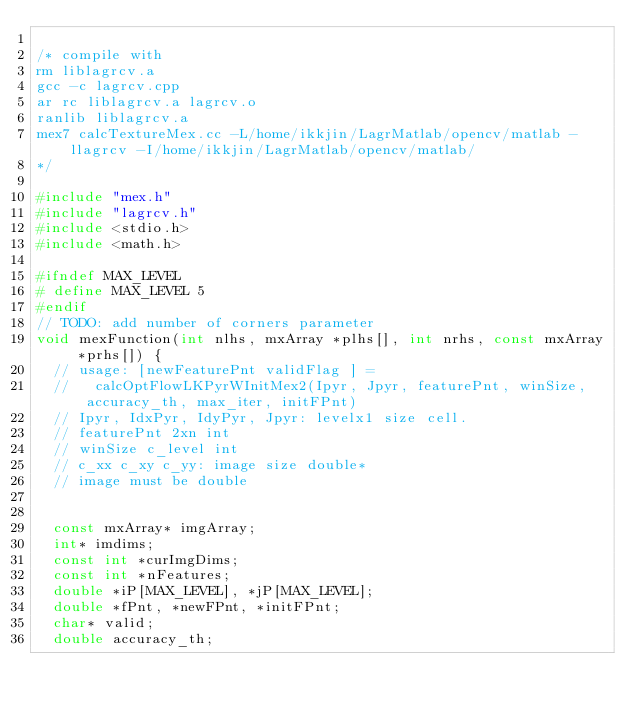<code> <loc_0><loc_0><loc_500><loc_500><_C++_>
/* compile with 
rm liblagrcv.a
gcc -c lagrcv.cpp
ar rc liblagrcv.a lagrcv.o
ranlib liblagrcv.a
mex7 calcTextureMex.cc -L/home/ikkjin/LagrMatlab/opencv/matlab -llagrcv -I/home/ikkjin/LagrMatlab/opencv/matlab/
*/

#include "mex.h"
#include "lagrcv.h"
#include <stdio.h>
#include <math.h>

#ifndef MAX_LEVEL
#	define MAX_LEVEL 5
#endif
// TODO: add number of corners parameter
void mexFunction(int nlhs, mxArray *plhs[], int nrhs, const mxArray *prhs[]) {
  // usage: [newFeaturePnt validFlag ] = 
  //   calcOptFlowLKPyrWInitMex2(Ipyr, Jpyr, featurePnt, winSize, accuracy_th, max_iter, initFPnt)
  // Ipyr, IdxPyr, IdyPyr, Jpyr: levelx1 size cell.
  // featurePnt 2xn int
  // winSize c_level int
  // c_xx c_xy c_yy: image size double*
  // image must be double

  
  const mxArray* imgArray;
  int* imdims;
  const int *curImgDims;
  const int *nFeatures;
  double *iP[MAX_LEVEL], *jP[MAX_LEVEL];
  double *fPnt, *newFPnt, *initFPnt; 
  char* valid;
  double accuracy_th;</code> 